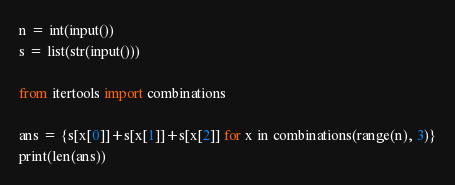<code> <loc_0><loc_0><loc_500><loc_500><_Python_>n = int(input())
s = list(str(input()))

from itertools import combinations

ans = {s[x[0]]+s[x[1]]+s[x[2]] for x in combinations(range(n), 3)}
print(len(ans))
</code> 